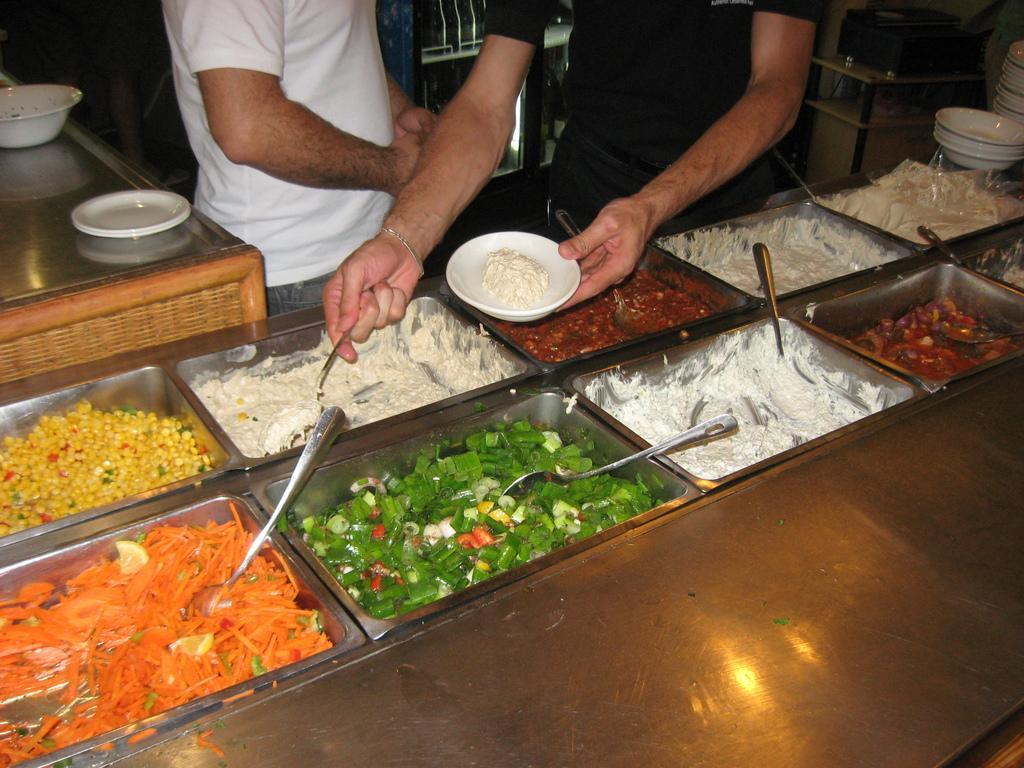Can you describe this image briefly? In this picture we can see bowl, we can see food and spoons present on these bowls, on the left side there is a counter top, we can see a plate and a bowl present on the counter top, there are two persons standing in the middle, a person on the right side is holding a spoon and a plate, on the right side there are some bowls. 